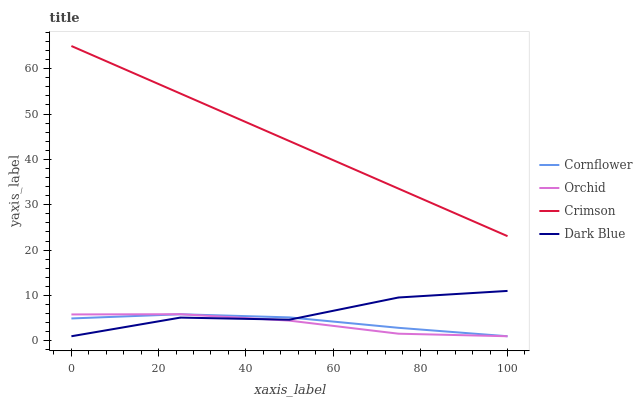Does Orchid have the minimum area under the curve?
Answer yes or no. Yes. Does Crimson have the maximum area under the curve?
Answer yes or no. Yes. Does Cornflower have the minimum area under the curve?
Answer yes or no. No. Does Cornflower have the maximum area under the curve?
Answer yes or no. No. Is Crimson the smoothest?
Answer yes or no. Yes. Is Dark Blue the roughest?
Answer yes or no. Yes. Is Cornflower the smoothest?
Answer yes or no. No. Is Cornflower the roughest?
Answer yes or no. No. Does Cornflower have the lowest value?
Answer yes or no. Yes. Does Crimson have the highest value?
Answer yes or no. Yes. Does Dark Blue have the highest value?
Answer yes or no. No. Is Dark Blue less than Crimson?
Answer yes or no. Yes. Is Crimson greater than Orchid?
Answer yes or no. Yes. Does Orchid intersect Dark Blue?
Answer yes or no. Yes. Is Orchid less than Dark Blue?
Answer yes or no. No. Is Orchid greater than Dark Blue?
Answer yes or no. No. Does Dark Blue intersect Crimson?
Answer yes or no. No. 